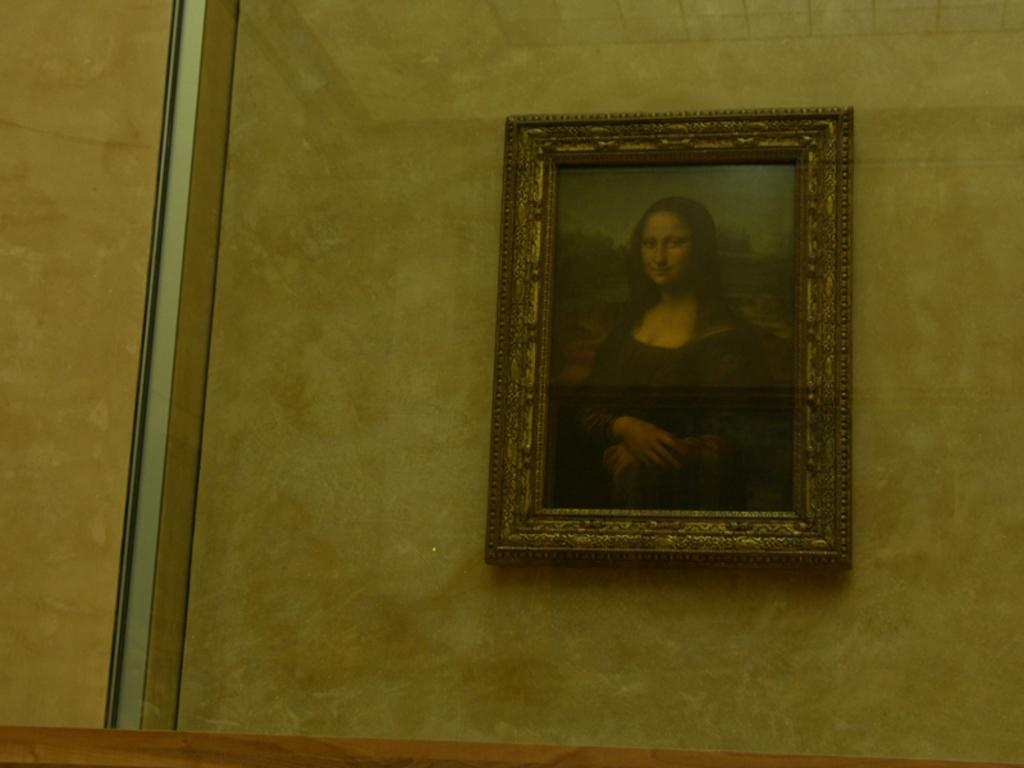What object is visible in the image? There is a glass in the image. What is inside the glass? Inside the glass, there is a wall. What can be seen on the wall inside the glass? There is a photo frame of a lady on the wall. How does the brake system work in the image? There is no brake system present in the image; it features a glass with a wall and a photo frame of a lady. What type of salt is used to season the food in the image? There is no food or salt present in the image; it features a glass with a wall and a photo frame of a lady. 